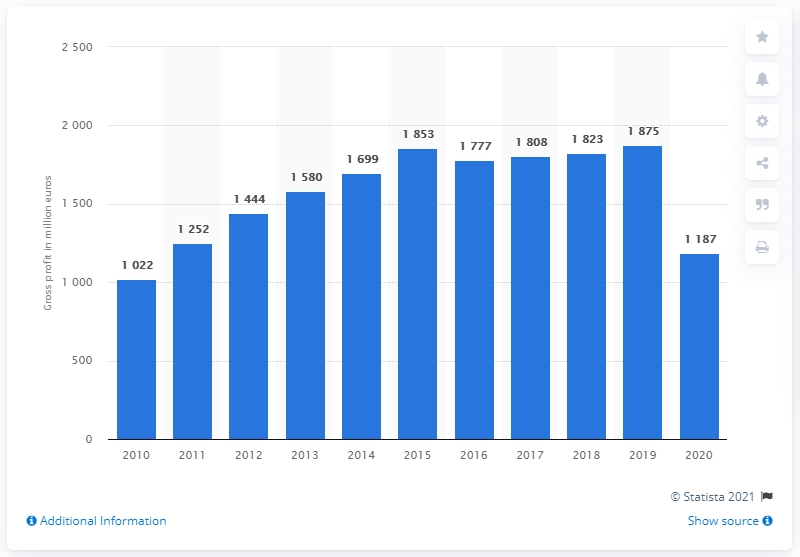Indicate a few pertinent items in this graphic. In 2020, the gross profit of Hugo Boss was 1,187. 